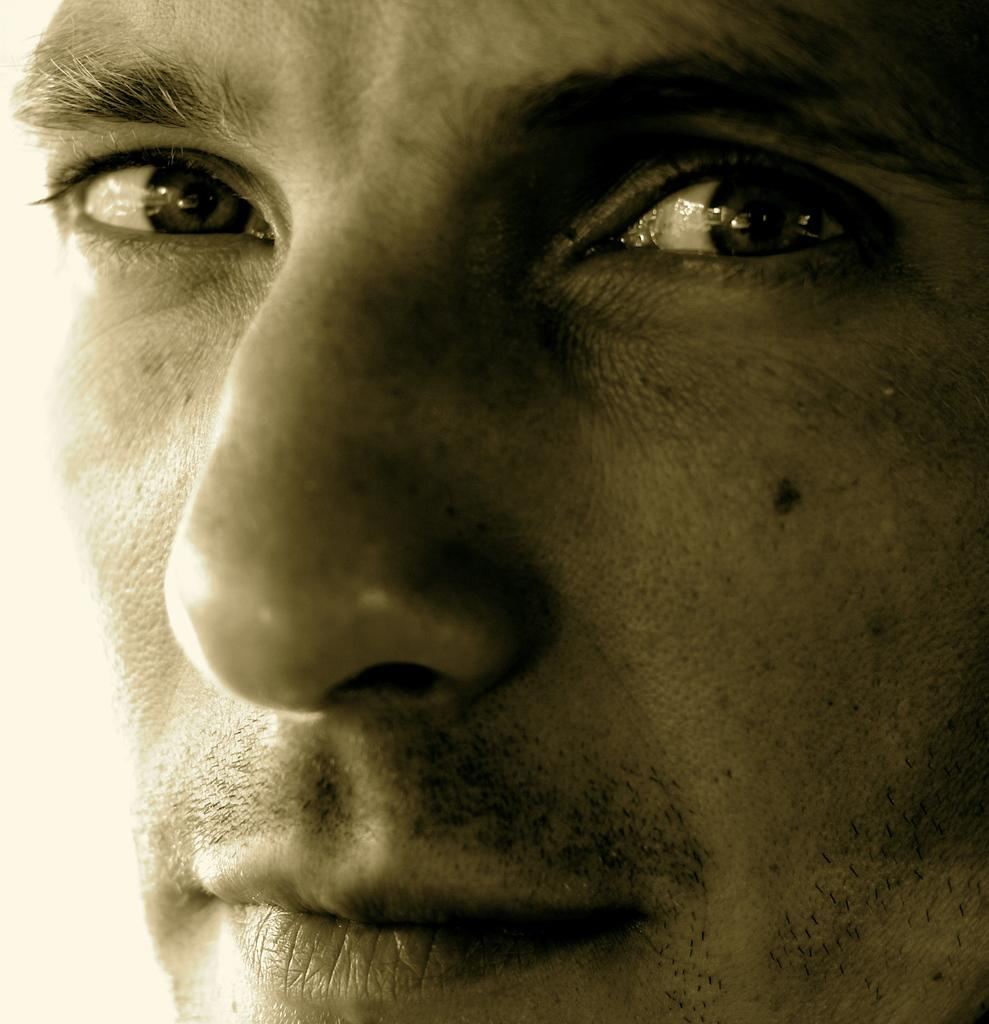What is the main subject of the image? There is a person's face in the image. What type of calculator is being used in the image? There is no calculator present in the image; it features a person's face. What type of battle is depicted in the image? There is no battle depicted in the image; it features a person's face. 